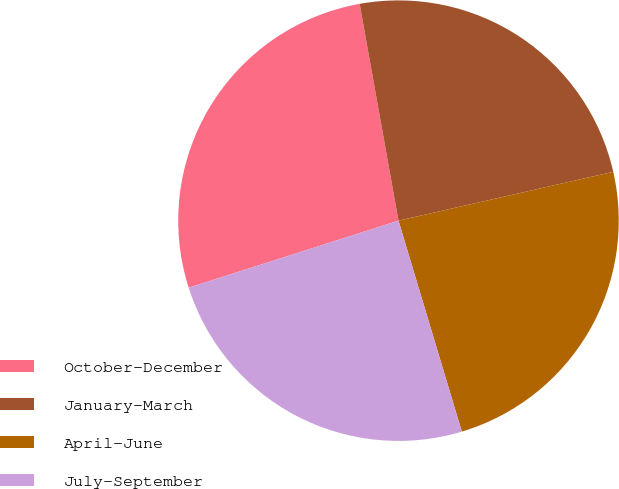<chart> <loc_0><loc_0><loc_500><loc_500><pie_chart><fcel>October-December<fcel>January-March<fcel>April-June<fcel>July-September<nl><fcel>27.1%<fcel>24.26%<fcel>23.92%<fcel>24.72%<nl></chart> 